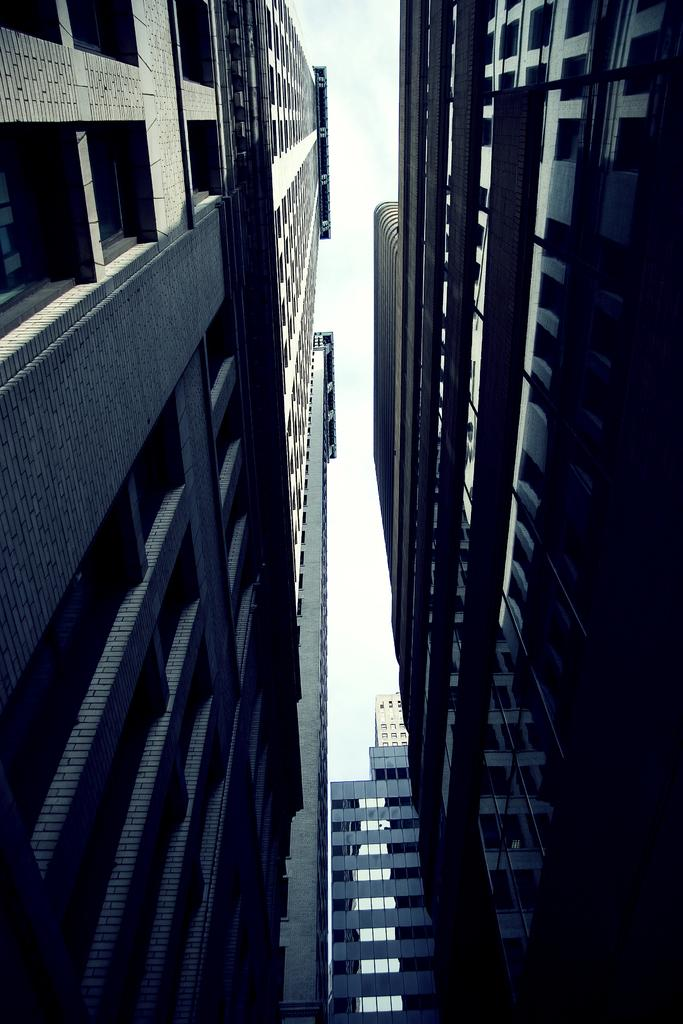What type of structures can be seen in the image? There are buildings in the image. What part of the natural environment is visible in the image? The sky is visible in the background of the image. How many cows can be seen in the image? There are no cows present in the image. Why are the people in the image crying? There are no people present in the image, so it is not possible to determine if they are crying. 